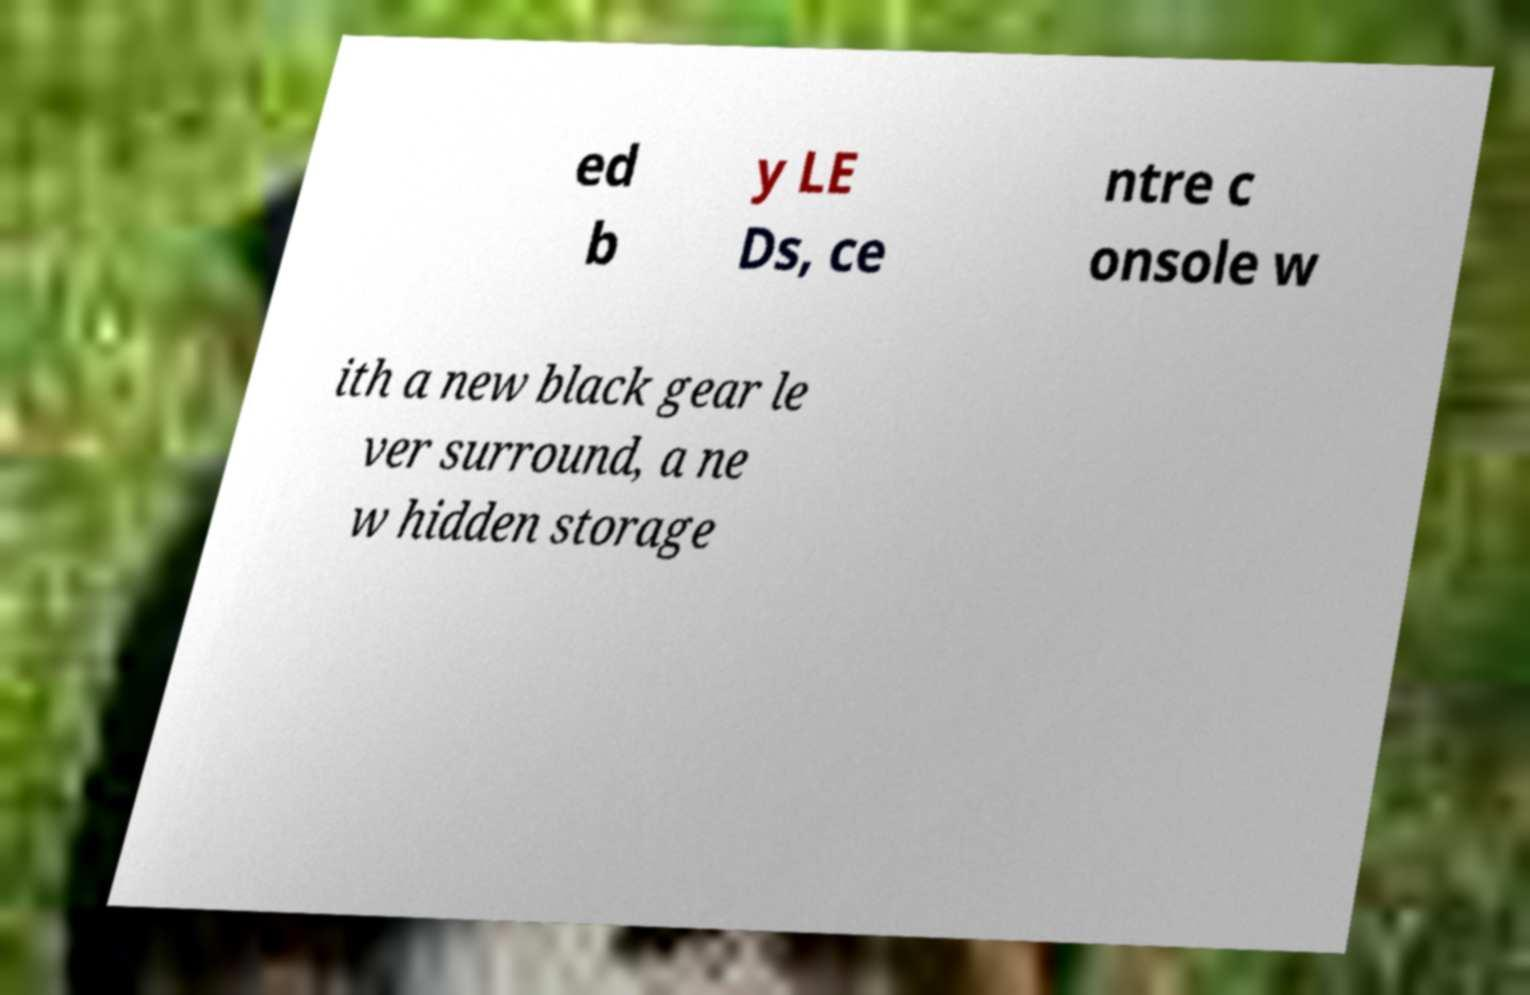There's text embedded in this image that I need extracted. Can you transcribe it verbatim? ed b y LE Ds, ce ntre c onsole w ith a new black gear le ver surround, a ne w hidden storage 